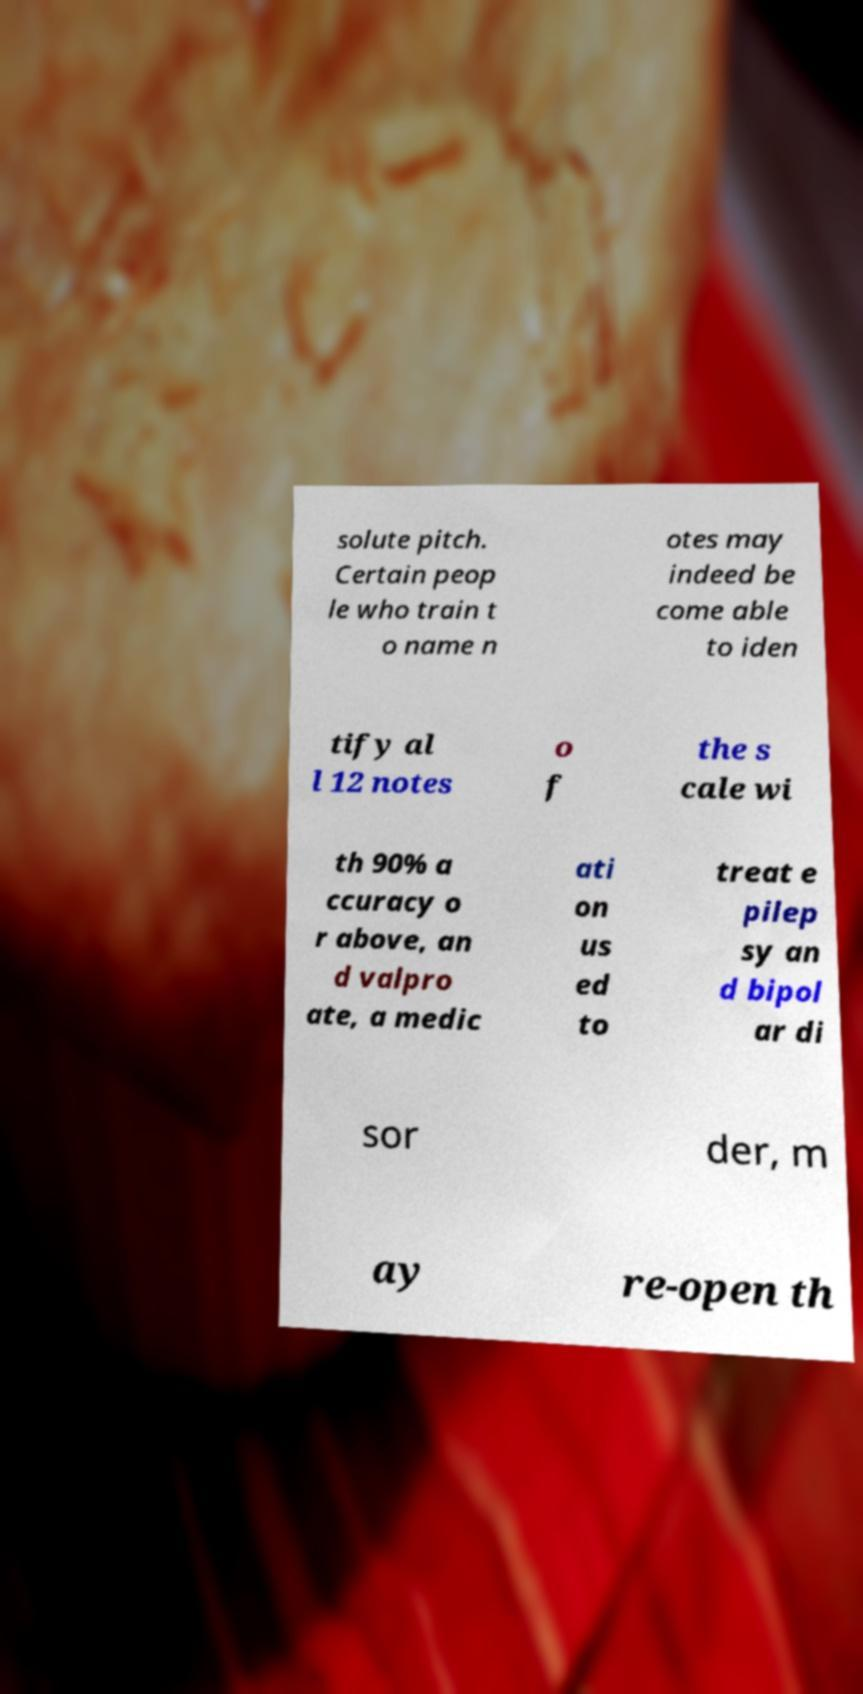Please identify and transcribe the text found in this image. solute pitch. Certain peop le who train t o name n otes may indeed be come able to iden tify al l 12 notes o f the s cale wi th 90% a ccuracy o r above, an d valpro ate, a medic ati on us ed to treat e pilep sy an d bipol ar di sor der, m ay re-open th 